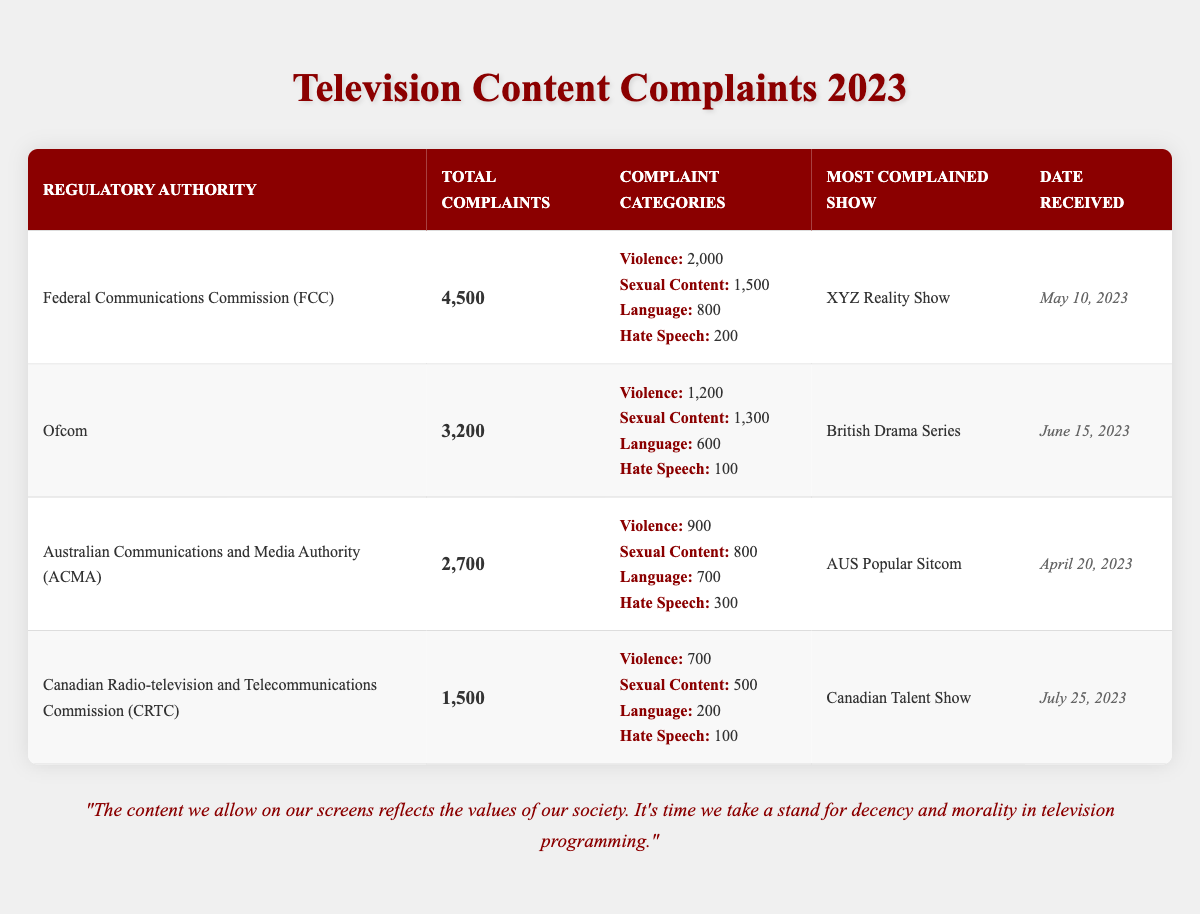What is the total number of complaints received by the Federal Communications Commission? According to the table, the Federal Communications Commission received a total of 4,500 complaints.
Answer: 4,500 Which show received the most complaints under Ofcom? The table shows that the British Drama Series is the most complained about show under Ofcom.
Answer: British Drama Series What percentage of the total complaints at the Australian Communications and Media Authority were related to violence? The ACMA received a total of 2,700 complaints, with 900 categorized as violence. The percentage is calculated as (900/2700) * 100 = 33.33%.
Answer: 33.33% Is the complaint category 'Hate Speech' the least complained about across all regulatory authorities? By comparing the hate speech complaints across all authorities, the FCC has 200, Ofcom has 100, ACMA has 300, and CRTC has 100. Since the CRTC has 300, hate speech is not the least complained about overall.
Answer: No What is the total number of sexual content complaints across all regulatory authorities? The total sexual content complaints are calculated by adding each authority's complaints: 1,500 (FCC) + 1,300 (Ofcom) + 800 (ACMA) + 500 (CRTC) = 4,100.
Answer: 4,100 Which regulatory authority had the highest number of language complaints? The table indicates that the Federal Communications Commission had the most language complaints with 800, compared to other authorities.
Answer: Federal Communications Commission How many complaints were received by the Canadian Radio-television and Telecommunications Commission compared to Ofcom? The CRTC received 1,500 complaints, while Ofcom received 3,200 complaints. The difference is 3,200 - 1,500 = 1,700 complaints more received by Ofcom.
Answer: Ofcom received 1,700 more complaints Which complaint category had the highest total across all regulatory authorities? Summing up each complaint category yields: Violence = 2,000 (FCC) + 1,200 (Ofcom) + 900 (ACMA) + 700 (CRTC) = 5,800, Sexual Content = 4,100, Language = 2,300, Hate Speech = 700. Hence, violence has the highest total.
Answer: Violence What is the most complained show received by the ACMA, and on what date? The ACMA received the most complaints about the AUS Popular Sitcom, which was reported on April 20, 2023.
Answer: AUS Popular Sitcom, April 20, 2023 